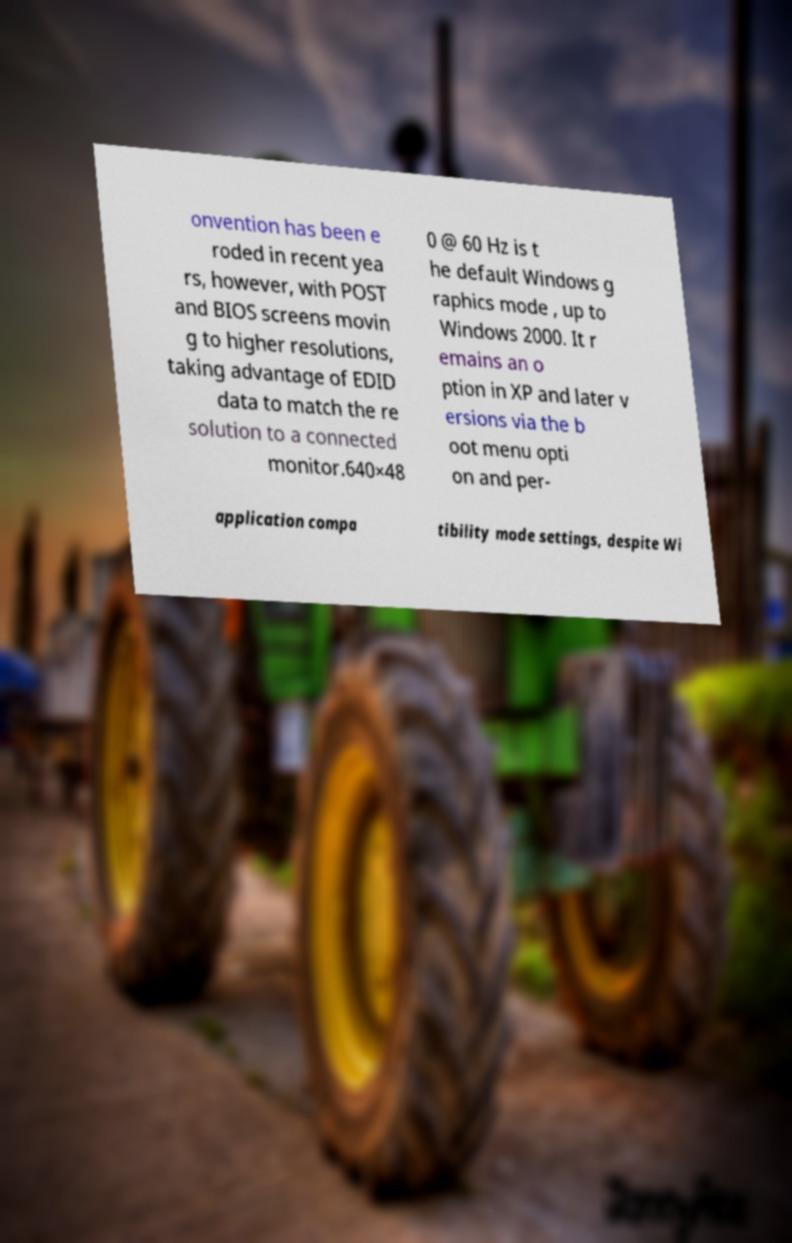There's text embedded in this image that I need extracted. Can you transcribe it verbatim? onvention has been e roded in recent yea rs, however, with POST and BIOS screens movin g to higher resolutions, taking advantage of EDID data to match the re solution to a connected monitor.640×48 0 @ 60 Hz is t he default Windows g raphics mode , up to Windows 2000. It r emains an o ption in XP and later v ersions via the b oot menu opti on and per- application compa tibility mode settings, despite Wi 